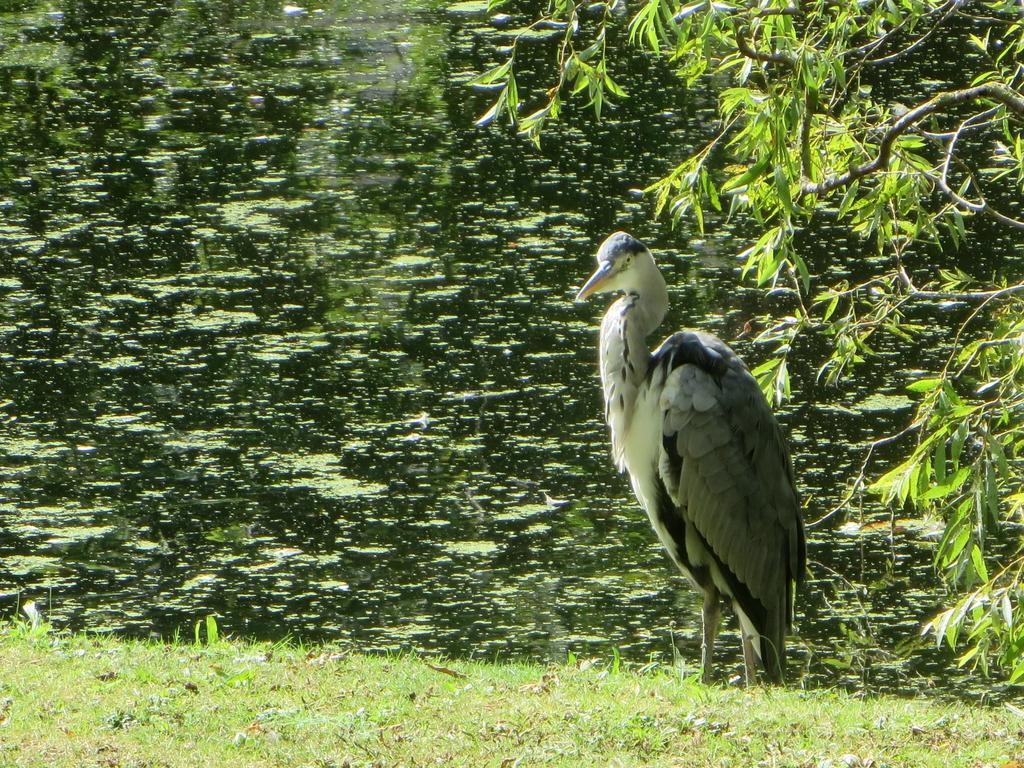How would you summarize this image in a sentence or two? In the image we can see a bird, grass, water and leaves. 